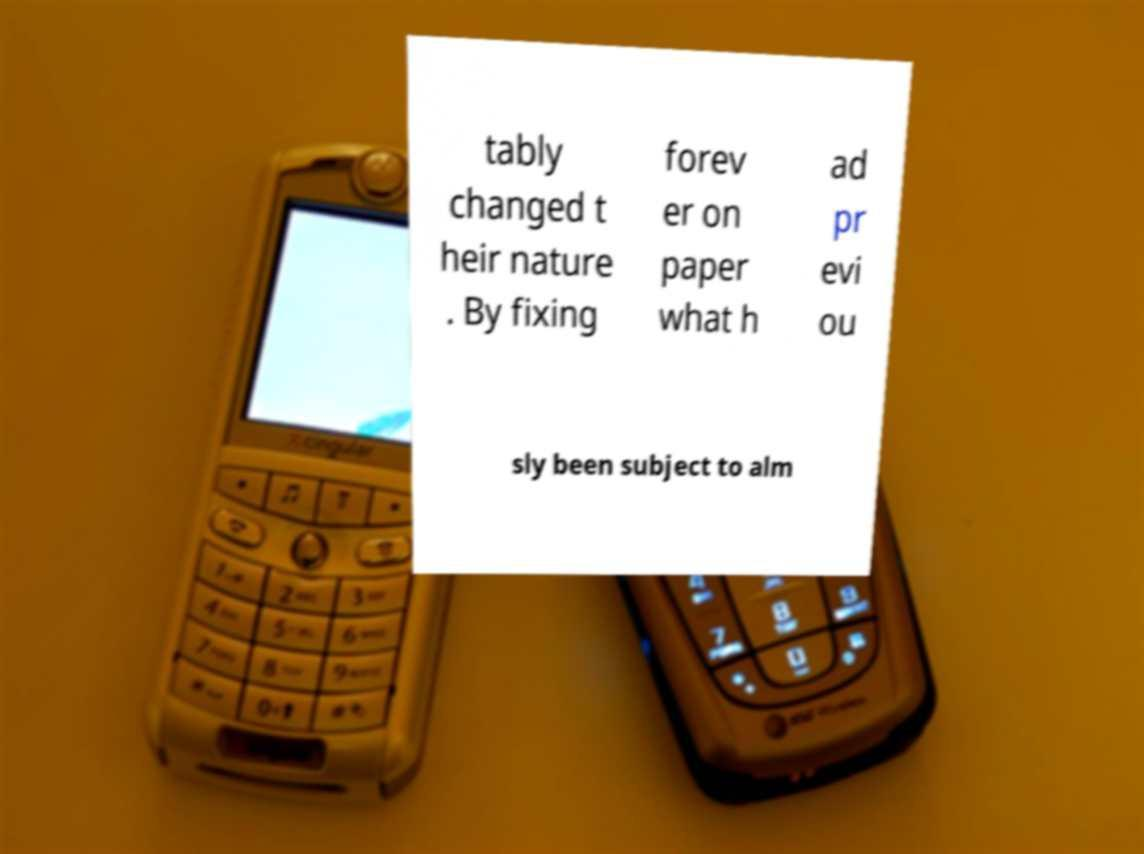Could you extract and type out the text from this image? tably changed t heir nature . By fixing forev er on paper what h ad pr evi ou sly been subject to alm 